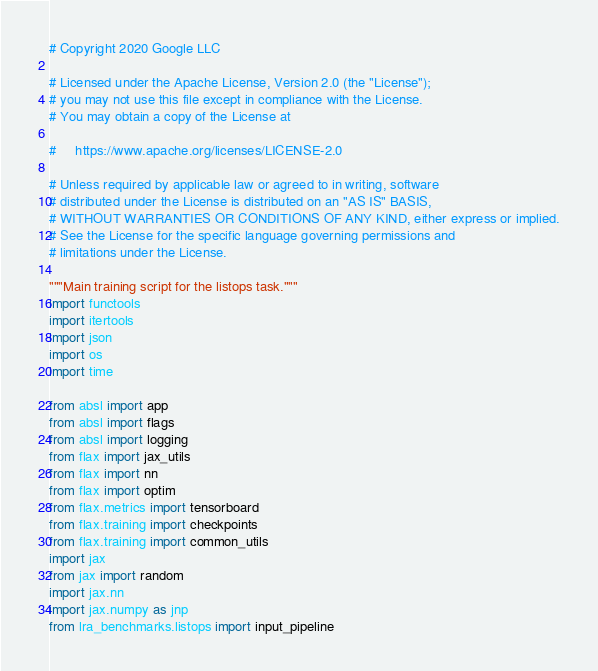Convert code to text. <code><loc_0><loc_0><loc_500><loc_500><_Python_># Copyright 2020 Google LLC

# Licensed under the Apache License, Version 2.0 (the "License");
# you may not use this file except in compliance with the License.
# You may obtain a copy of the License at

#     https://www.apache.org/licenses/LICENSE-2.0

# Unless required by applicable law or agreed to in writing, software
# distributed under the License is distributed on an "AS IS" BASIS,
# WITHOUT WARRANTIES OR CONDITIONS OF ANY KIND, either express or implied.
# See the License for the specific language governing permissions and
# limitations under the License.

"""Main training script for the listops task."""
import functools
import itertools
import json
import os
import time

from absl import app
from absl import flags
from absl import logging
from flax import jax_utils
from flax import nn
from flax import optim
from flax.metrics import tensorboard
from flax.training import checkpoints
from flax.training import common_utils
import jax
from jax import random
import jax.nn
import jax.numpy as jnp
from lra_benchmarks.listops import input_pipeline</code> 